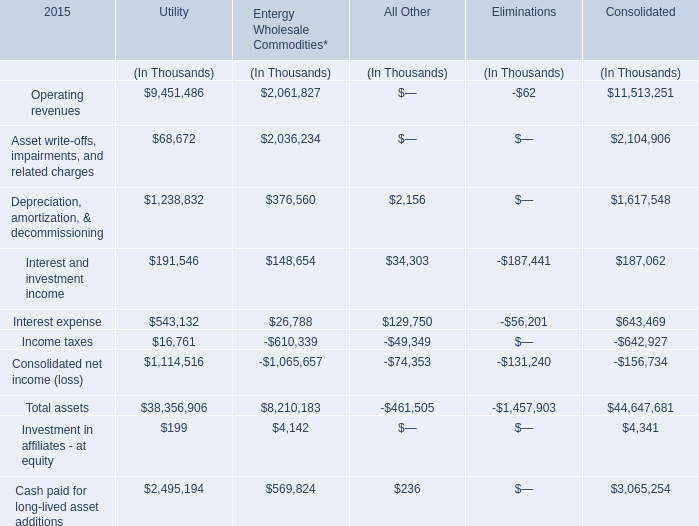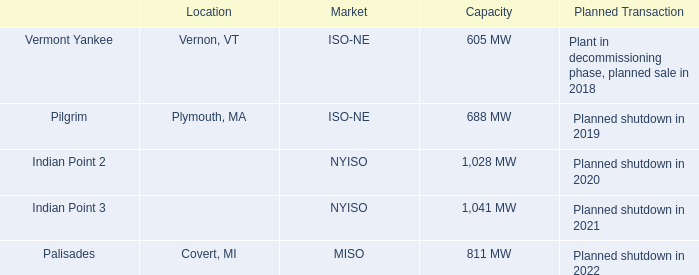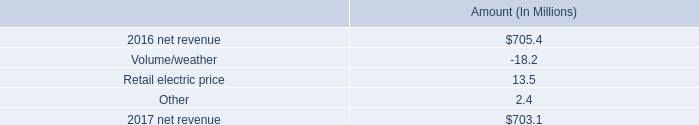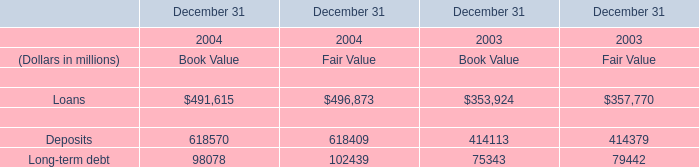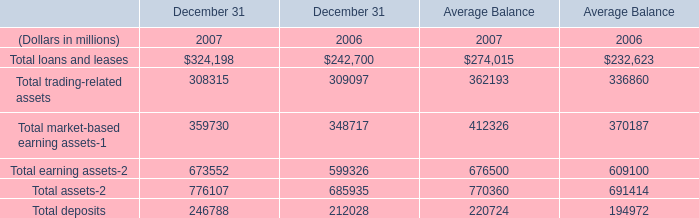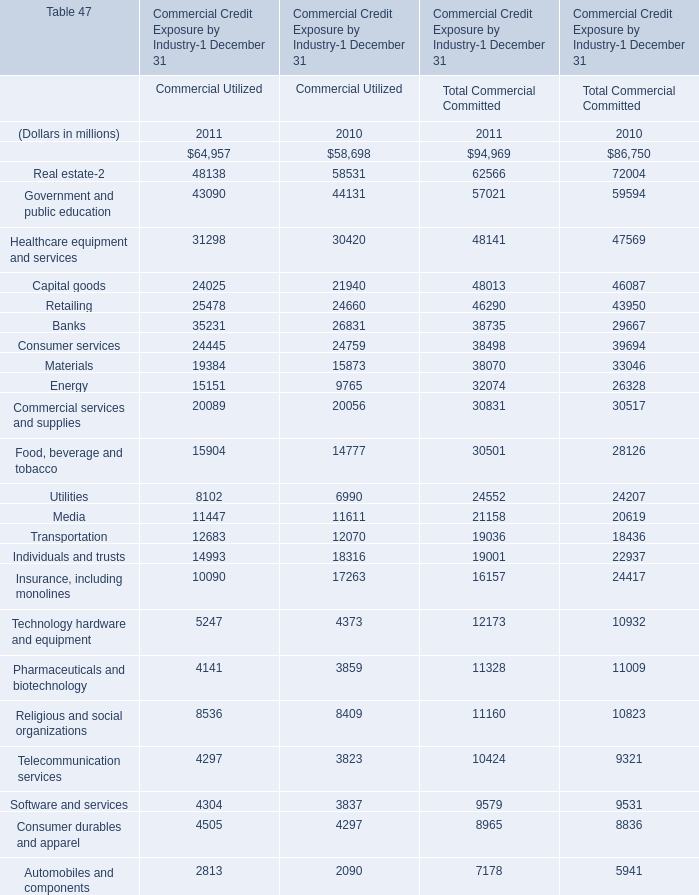In the year with largest amount of Diversified financials in table 2, what's the increasing rate of Capital goods in table 2? 
Computations: ((((24025 + 48013) - 21940) - 46087) / (21940 + 46087))
Answer: 0.05896. 